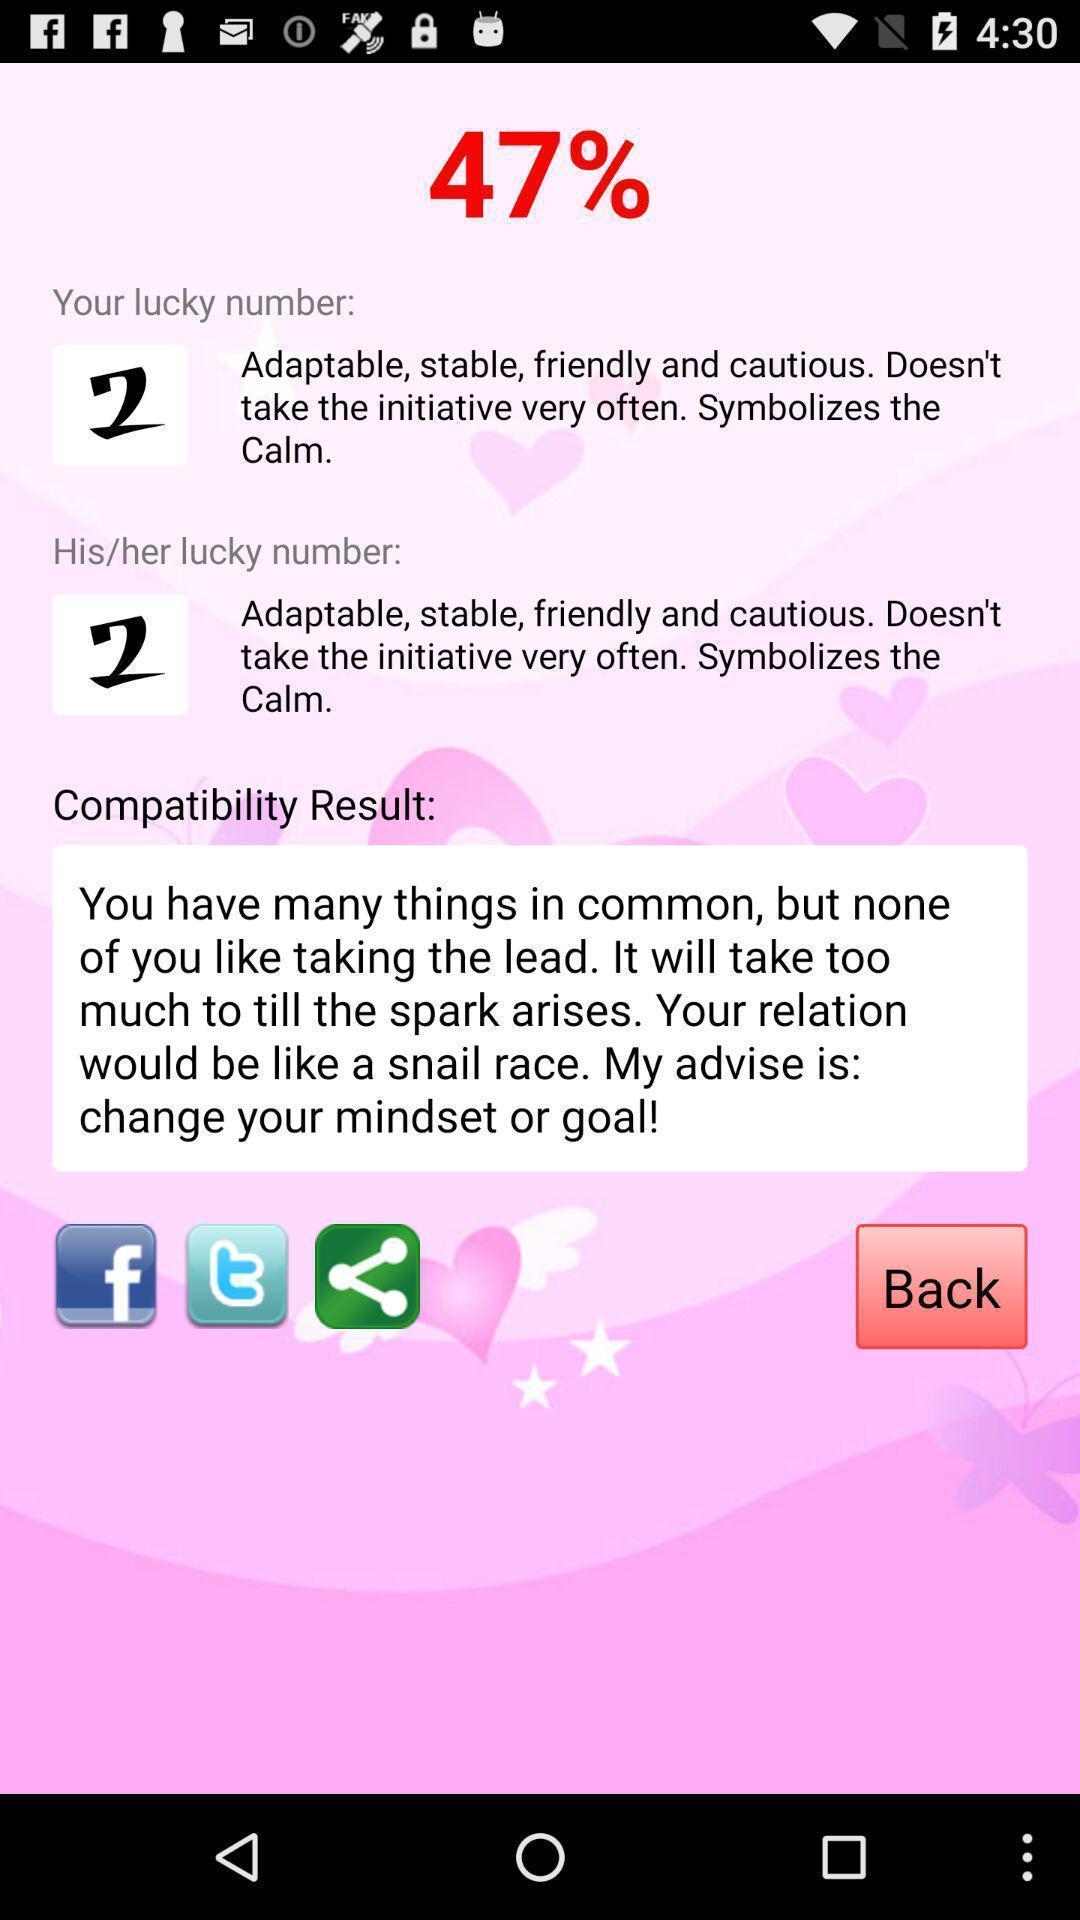Give me a summary of this screen capture. Screen shows a compatibility result of signs. 